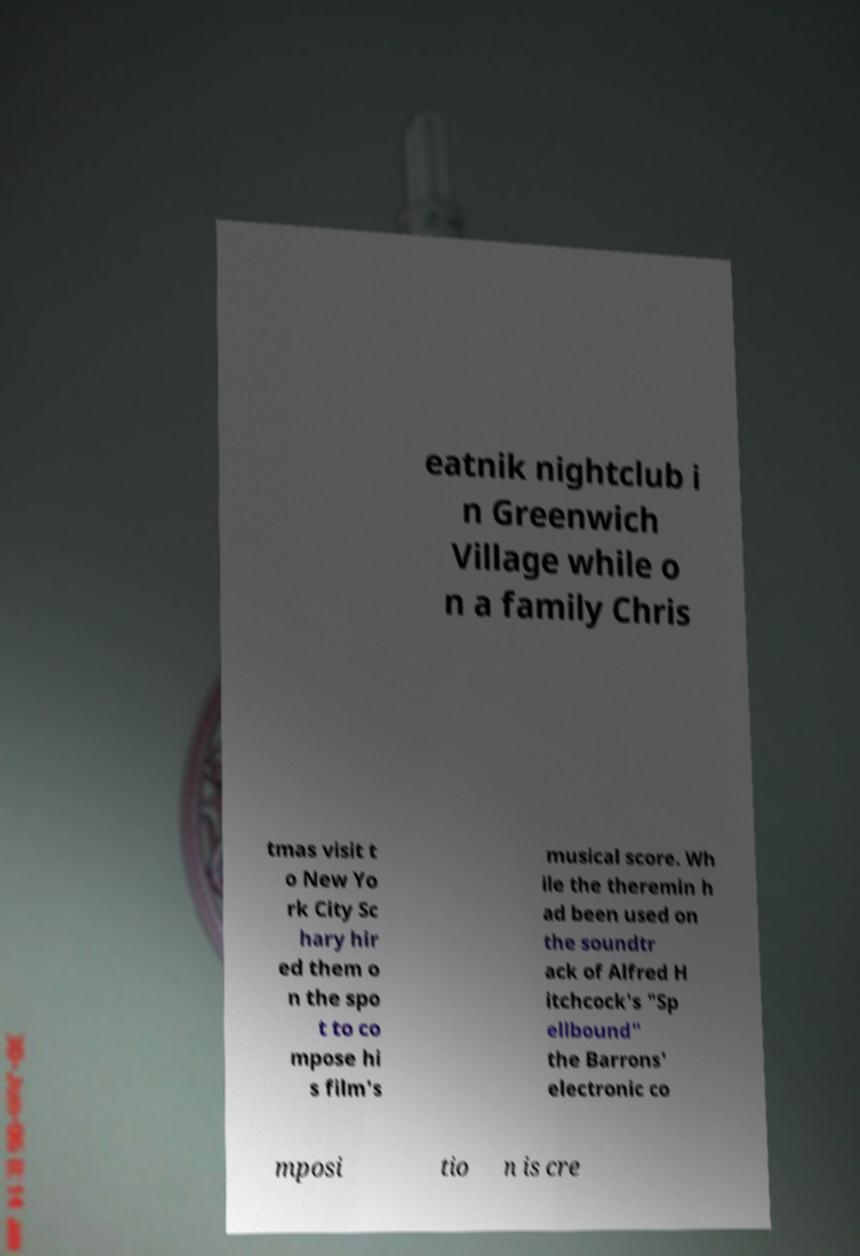Please read and relay the text visible in this image. What does it say? eatnik nightclub i n Greenwich Village while o n a family Chris tmas visit t o New Yo rk City Sc hary hir ed them o n the spo t to co mpose hi s film's musical score. Wh ile the theremin h ad been used on the soundtr ack of Alfred H itchcock's "Sp ellbound" the Barrons' electronic co mposi tio n is cre 